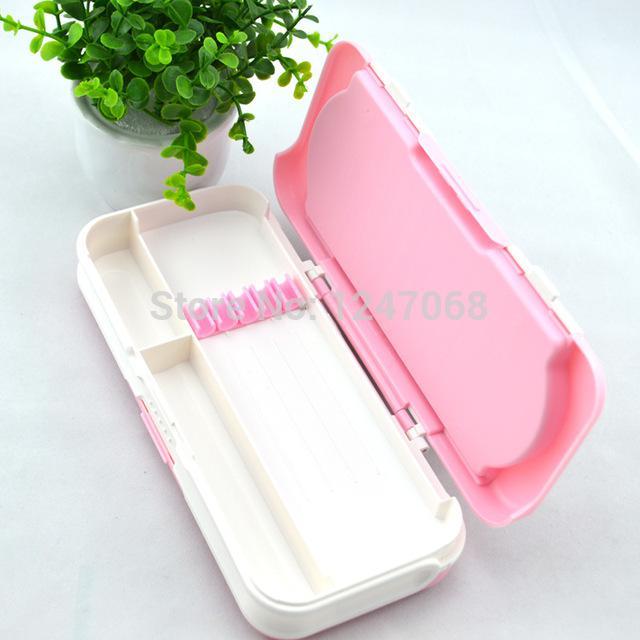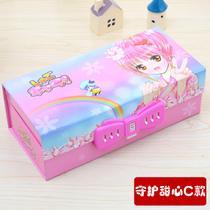The first image is the image on the left, the second image is the image on the right. Assess this claim about the two images: "One image shows a closed hard-sided pencil case with a big-eyed cartoon girl on the front, and the other shows an open pink-and-white case.". Correct or not? Answer yes or no. Yes. The first image is the image on the left, the second image is the image on the right. For the images shown, is this caption "At least one of the pencil cases opens and closes with a zipper." true? Answer yes or no. No. 